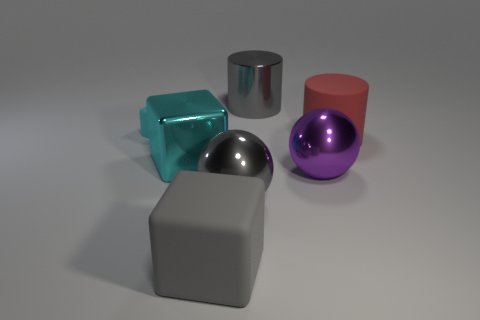What shape is the red object that is the same size as the gray metal cylinder?
Your answer should be compact. Cylinder. Are there the same number of tiny matte objects behind the gray cube and gray metallic things that are to the right of the large red object?
Your response must be concise. No. There is a cylinder that is on the right side of the cylinder behind the cyan rubber object; how big is it?
Make the answer very short. Large. Is there a gray cylinder that has the same size as the gray shiny ball?
Give a very brief answer. Yes. There is a tiny cube that is made of the same material as the large red cylinder; what is its color?
Your answer should be very brief. Cyan. Are there fewer tiny objects than shiny balls?
Provide a short and direct response. Yes. What is the object that is behind the big cyan cube and to the left of the large gray shiny cylinder made of?
Your answer should be compact. Rubber. There is a big block that is in front of the purple metal sphere; are there any big things that are behind it?
Provide a short and direct response. Yes. How many big rubber cylinders are the same color as the small cube?
Provide a short and direct response. 0. There is a big object that is the same color as the tiny rubber thing; what is it made of?
Offer a terse response. Metal. 